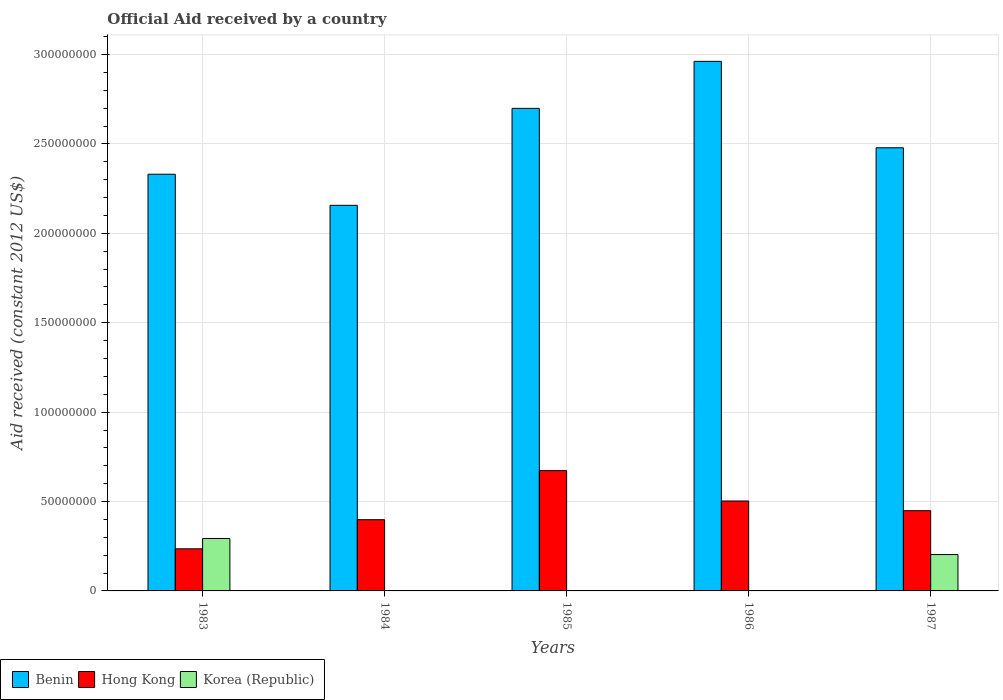How many groups of bars are there?
Keep it short and to the point. 5. How many bars are there on the 1st tick from the left?
Offer a terse response. 3. How many bars are there on the 4th tick from the right?
Provide a short and direct response. 2. In how many cases, is the number of bars for a given year not equal to the number of legend labels?
Your answer should be compact. 3. What is the net official aid received in Benin in 1985?
Make the answer very short. 2.70e+08. Across all years, what is the maximum net official aid received in Korea (Republic)?
Offer a terse response. 2.93e+07. Across all years, what is the minimum net official aid received in Hong Kong?
Your response must be concise. 2.36e+07. What is the total net official aid received in Korea (Republic) in the graph?
Your answer should be very brief. 4.96e+07. What is the difference between the net official aid received in Hong Kong in 1984 and that in 1987?
Your answer should be compact. -5.04e+06. What is the difference between the net official aid received in Benin in 1985 and the net official aid received in Hong Kong in 1984?
Provide a short and direct response. 2.30e+08. What is the average net official aid received in Benin per year?
Provide a succinct answer. 2.53e+08. In the year 1983, what is the difference between the net official aid received in Benin and net official aid received in Hong Kong?
Offer a terse response. 2.10e+08. What is the ratio of the net official aid received in Benin in 1984 to that in 1986?
Offer a very short reply. 0.73. Is the net official aid received in Hong Kong in 1983 less than that in 1984?
Your response must be concise. Yes. What is the difference between the highest and the second highest net official aid received in Benin?
Your answer should be compact. 2.63e+07. What is the difference between the highest and the lowest net official aid received in Hong Kong?
Your answer should be compact. 4.37e+07. In how many years, is the net official aid received in Hong Kong greater than the average net official aid received in Hong Kong taken over all years?
Make the answer very short. 2. How many bars are there?
Offer a terse response. 12. Where does the legend appear in the graph?
Offer a very short reply. Bottom left. What is the title of the graph?
Ensure brevity in your answer.  Official Aid received by a country. Does "Angola" appear as one of the legend labels in the graph?
Make the answer very short. No. What is the label or title of the X-axis?
Offer a very short reply. Years. What is the label or title of the Y-axis?
Offer a terse response. Aid received (constant 2012 US$). What is the Aid received (constant 2012 US$) in Benin in 1983?
Offer a terse response. 2.33e+08. What is the Aid received (constant 2012 US$) in Hong Kong in 1983?
Give a very brief answer. 2.36e+07. What is the Aid received (constant 2012 US$) of Korea (Republic) in 1983?
Make the answer very short. 2.93e+07. What is the Aid received (constant 2012 US$) of Benin in 1984?
Your response must be concise. 2.16e+08. What is the Aid received (constant 2012 US$) in Hong Kong in 1984?
Provide a succinct answer. 3.98e+07. What is the Aid received (constant 2012 US$) in Benin in 1985?
Your answer should be compact. 2.70e+08. What is the Aid received (constant 2012 US$) in Hong Kong in 1985?
Offer a very short reply. 6.73e+07. What is the Aid received (constant 2012 US$) in Korea (Republic) in 1985?
Your answer should be compact. 0. What is the Aid received (constant 2012 US$) in Benin in 1986?
Provide a short and direct response. 2.96e+08. What is the Aid received (constant 2012 US$) of Hong Kong in 1986?
Offer a very short reply. 5.03e+07. What is the Aid received (constant 2012 US$) in Korea (Republic) in 1986?
Make the answer very short. 0. What is the Aid received (constant 2012 US$) in Benin in 1987?
Your answer should be compact. 2.48e+08. What is the Aid received (constant 2012 US$) of Hong Kong in 1987?
Your response must be concise. 4.49e+07. What is the Aid received (constant 2012 US$) of Korea (Republic) in 1987?
Give a very brief answer. 2.03e+07. Across all years, what is the maximum Aid received (constant 2012 US$) in Benin?
Offer a very short reply. 2.96e+08. Across all years, what is the maximum Aid received (constant 2012 US$) of Hong Kong?
Offer a very short reply. 6.73e+07. Across all years, what is the maximum Aid received (constant 2012 US$) in Korea (Republic)?
Provide a short and direct response. 2.93e+07. Across all years, what is the minimum Aid received (constant 2012 US$) in Benin?
Your response must be concise. 2.16e+08. Across all years, what is the minimum Aid received (constant 2012 US$) of Hong Kong?
Keep it short and to the point. 2.36e+07. What is the total Aid received (constant 2012 US$) in Benin in the graph?
Your answer should be compact. 1.26e+09. What is the total Aid received (constant 2012 US$) of Hong Kong in the graph?
Your response must be concise. 2.26e+08. What is the total Aid received (constant 2012 US$) of Korea (Republic) in the graph?
Ensure brevity in your answer.  4.96e+07. What is the difference between the Aid received (constant 2012 US$) in Benin in 1983 and that in 1984?
Keep it short and to the point. 1.74e+07. What is the difference between the Aid received (constant 2012 US$) in Hong Kong in 1983 and that in 1984?
Give a very brief answer. -1.63e+07. What is the difference between the Aid received (constant 2012 US$) in Benin in 1983 and that in 1985?
Provide a short and direct response. -3.68e+07. What is the difference between the Aid received (constant 2012 US$) of Hong Kong in 1983 and that in 1985?
Your response must be concise. -4.37e+07. What is the difference between the Aid received (constant 2012 US$) in Benin in 1983 and that in 1986?
Make the answer very short. -6.31e+07. What is the difference between the Aid received (constant 2012 US$) in Hong Kong in 1983 and that in 1986?
Provide a short and direct response. -2.68e+07. What is the difference between the Aid received (constant 2012 US$) of Benin in 1983 and that in 1987?
Your response must be concise. -1.48e+07. What is the difference between the Aid received (constant 2012 US$) of Hong Kong in 1983 and that in 1987?
Make the answer very short. -2.13e+07. What is the difference between the Aid received (constant 2012 US$) in Korea (Republic) in 1983 and that in 1987?
Offer a very short reply. 8.97e+06. What is the difference between the Aid received (constant 2012 US$) of Benin in 1984 and that in 1985?
Your answer should be compact. -5.42e+07. What is the difference between the Aid received (constant 2012 US$) of Hong Kong in 1984 and that in 1985?
Give a very brief answer. -2.74e+07. What is the difference between the Aid received (constant 2012 US$) of Benin in 1984 and that in 1986?
Offer a very short reply. -8.05e+07. What is the difference between the Aid received (constant 2012 US$) of Hong Kong in 1984 and that in 1986?
Your answer should be compact. -1.05e+07. What is the difference between the Aid received (constant 2012 US$) in Benin in 1984 and that in 1987?
Provide a short and direct response. -3.22e+07. What is the difference between the Aid received (constant 2012 US$) in Hong Kong in 1984 and that in 1987?
Offer a terse response. -5.04e+06. What is the difference between the Aid received (constant 2012 US$) of Benin in 1985 and that in 1986?
Ensure brevity in your answer.  -2.63e+07. What is the difference between the Aid received (constant 2012 US$) in Hong Kong in 1985 and that in 1986?
Keep it short and to the point. 1.70e+07. What is the difference between the Aid received (constant 2012 US$) in Benin in 1985 and that in 1987?
Your answer should be very brief. 2.20e+07. What is the difference between the Aid received (constant 2012 US$) of Hong Kong in 1985 and that in 1987?
Your answer should be very brief. 2.24e+07. What is the difference between the Aid received (constant 2012 US$) of Benin in 1986 and that in 1987?
Your answer should be very brief. 4.83e+07. What is the difference between the Aid received (constant 2012 US$) in Hong Kong in 1986 and that in 1987?
Make the answer very short. 5.43e+06. What is the difference between the Aid received (constant 2012 US$) in Benin in 1983 and the Aid received (constant 2012 US$) in Hong Kong in 1984?
Ensure brevity in your answer.  1.93e+08. What is the difference between the Aid received (constant 2012 US$) in Benin in 1983 and the Aid received (constant 2012 US$) in Hong Kong in 1985?
Ensure brevity in your answer.  1.66e+08. What is the difference between the Aid received (constant 2012 US$) of Benin in 1983 and the Aid received (constant 2012 US$) of Hong Kong in 1986?
Your answer should be very brief. 1.83e+08. What is the difference between the Aid received (constant 2012 US$) of Benin in 1983 and the Aid received (constant 2012 US$) of Hong Kong in 1987?
Give a very brief answer. 1.88e+08. What is the difference between the Aid received (constant 2012 US$) of Benin in 1983 and the Aid received (constant 2012 US$) of Korea (Republic) in 1987?
Give a very brief answer. 2.13e+08. What is the difference between the Aid received (constant 2012 US$) in Hong Kong in 1983 and the Aid received (constant 2012 US$) in Korea (Republic) in 1987?
Your response must be concise. 3.21e+06. What is the difference between the Aid received (constant 2012 US$) of Benin in 1984 and the Aid received (constant 2012 US$) of Hong Kong in 1985?
Offer a very short reply. 1.48e+08. What is the difference between the Aid received (constant 2012 US$) of Benin in 1984 and the Aid received (constant 2012 US$) of Hong Kong in 1986?
Keep it short and to the point. 1.65e+08. What is the difference between the Aid received (constant 2012 US$) of Benin in 1984 and the Aid received (constant 2012 US$) of Hong Kong in 1987?
Keep it short and to the point. 1.71e+08. What is the difference between the Aid received (constant 2012 US$) of Benin in 1984 and the Aid received (constant 2012 US$) of Korea (Republic) in 1987?
Provide a short and direct response. 1.95e+08. What is the difference between the Aid received (constant 2012 US$) in Hong Kong in 1984 and the Aid received (constant 2012 US$) in Korea (Republic) in 1987?
Provide a succinct answer. 1.95e+07. What is the difference between the Aid received (constant 2012 US$) in Benin in 1985 and the Aid received (constant 2012 US$) in Hong Kong in 1986?
Your answer should be compact. 2.20e+08. What is the difference between the Aid received (constant 2012 US$) in Benin in 1985 and the Aid received (constant 2012 US$) in Hong Kong in 1987?
Ensure brevity in your answer.  2.25e+08. What is the difference between the Aid received (constant 2012 US$) in Benin in 1985 and the Aid received (constant 2012 US$) in Korea (Republic) in 1987?
Keep it short and to the point. 2.50e+08. What is the difference between the Aid received (constant 2012 US$) of Hong Kong in 1985 and the Aid received (constant 2012 US$) of Korea (Republic) in 1987?
Offer a very short reply. 4.69e+07. What is the difference between the Aid received (constant 2012 US$) in Benin in 1986 and the Aid received (constant 2012 US$) in Hong Kong in 1987?
Provide a short and direct response. 2.51e+08. What is the difference between the Aid received (constant 2012 US$) in Benin in 1986 and the Aid received (constant 2012 US$) in Korea (Republic) in 1987?
Offer a terse response. 2.76e+08. What is the difference between the Aid received (constant 2012 US$) in Hong Kong in 1986 and the Aid received (constant 2012 US$) in Korea (Republic) in 1987?
Provide a succinct answer. 3.00e+07. What is the average Aid received (constant 2012 US$) of Benin per year?
Your answer should be very brief. 2.53e+08. What is the average Aid received (constant 2012 US$) of Hong Kong per year?
Keep it short and to the point. 4.52e+07. What is the average Aid received (constant 2012 US$) in Korea (Republic) per year?
Give a very brief answer. 9.93e+06. In the year 1983, what is the difference between the Aid received (constant 2012 US$) in Benin and Aid received (constant 2012 US$) in Hong Kong?
Ensure brevity in your answer.  2.10e+08. In the year 1983, what is the difference between the Aid received (constant 2012 US$) in Benin and Aid received (constant 2012 US$) in Korea (Republic)?
Your answer should be very brief. 2.04e+08. In the year 1983, what is the difference between the Aid received (constant 2012 US$) of Hong Kong and Aid received (constant 2012 US$) of Korea (Republic)?
Offer a terse response. -5.76e+06. In the year 1984, what is the difference between the Aid received (constant 2012 US$) in Benin and Aid received (constant 2012 US$) in Hong Kong?
Keep it short and to the point. 1.76e+08. In the year 1985, what is the difference between the Aid received (constant 2012 US$) in Benin and Aid received (constant 2012 US$) in Hong Kong?
Give a very brief answer. 2.03e+08. In the year 1986, what is the difference between the Aid received (constant 2012 US$) of Benin and Aid received (constant 2012 US$) of Hong Kong?
Offer a very short reply. 2.46e+08. In the year 1987, what is the difference between the Aid received (constant 2012 US$) of Benin and Aid received (constant 2012 US$) of Hong Kong?
Provide a short and direct response. 2.03e+08. In the year 1987, what is the difference between the Aid received (constant 2012 US$) of Benin and Aid received (constant 2012 US$) of Korea (Republic)?
Make the answer very short. 2.28e+08. In the year 1987, what is the difference between the Aid received (constant 2012 US$) in Hong Kong and Aid received (constant 2012 US$) in Korea (Republic)?
Offer a terse response. 2.45e+07. What is the ratio of the Aid received (constant 2012 US$) in Benin in 1983 to that in 1984?
Give a very brief answer. 1.08. What is the ratio of the Aid received (constant 2012 US$) of Hong Kong in 1983 to that in 1984?
Provide a short and direct response. 0.59. What is the ratio of the Aid received (constant 2012 US$) of Benin in 1983 to that in 1985?
Your answer should be compact. 0.86. What is the ratio of the Aid received (constant 2012 US$) of Benin in 1983 to that in 1986?
Your answer should be compact. 0.79. What is the ratio of the Aid received (constant 2012 US$) of Hong Kong in 1983 to that in 1986?
Provide a short and direct response. 0.47. What is the ratio of the Aid received (constant 2012 US$) in Benin in 1983 to that in 1987?
Your answer should be very brief. 0.94. What is the ratio of the Aid received (constant 2012 US$) in Hong Kong in 1983 to that in 1987?
Provide a succinct answer. 0.52. What is the ratio of the Aid received (constant 2012 US$) in Korea (Republic) in 1983 to that in 1987?
Provide a short and direct response. 1.44. What is the ratio of the Aid received (constant 2012 US$) of Benin in 1984 to that in 1985?
Give a very brief answer. 0.8. What is the ratio of the Aid received (constant 2012 US$) of Hong Kong in 1984 to that in 1985?
Make the answer very short. 0.59. What is the ratio of the Aid received (constant 2012 US$) in Benin in 1984 to that in 1986?
Keep it short and to the point. 0.73. What is the ratio of the Aid received (constant 2012 US$) of Hong Kong in 1984 to that in 1986?
Provide a short and direct response. 0.79. What is the ratio of the Aid received (constant 2012 US$) in Benin in 1984 to that in 1987?
Make the answer very short. 0.87. What is the ratio of the Aid received (constant 2012 US$) of Hong Kong in 1984 to that in 1987?
Provide a succinct answer. 0.89. What is the ratio of the Aid received (constant 2012 US$) of Benin in 1985 to that in 1986?
Make the answer very short. 0.91. What is the ratio of the Aid received (constant 2012 US$) in Hong Kong in 1985 to that in 1986?
Offer a very short reply. 1.34. What is the ratio of the Aid received (constant 2012 US$) of Benin in 1985 to that in 1987?
Give a very brief answer. 1.09. What is the ratio of the Aid received (constant 2012 US$) of Hong Kong in 1985 to that in 1987?
Your response must be concise. 1.5. What is the ratio of the Aid received (constant 2012 US$) of Benin in 1986 to that in 1987?
Ensure brevity in your answer.  1.2. What is the ratio of the Aid received (constant 2012 US$) of Hong Kong in 1986 to that in 1987?
Provide a succinct answer. 1.12. What is the difference between the highest and the second highest Aid received (constant 2012 US$) in Benin?
Provide a succinct answer. 2.63e+07. What is the difference between the highest and the second highest Aid received (constant 2012 US$) of Hong Kong?
Keep it short and to the point. 1.70e+07. What is the difference between the highest and the lowest Aid received (constant 2012 US$) in Benin?
Offer a terse response. 8.05e+07. What is the difference between the highest and the lowest Aid received (constant 2012 US$) of Hong Kong?
Give a very brief answer. 4.37e+07. What is the difference between the highest and the lowest Aid received (constant 2012 US$) in Korea (Republic)?
Your answer should be very brief. 2.93e+07. 